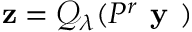Convert formula to latex. <formula><loc_0><loc_0><loc_500><loc_500>z = \mathcal { Q } _ { \lambda } ( P ^ { r } y )</formula> 